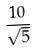<formula> <loc_0><loc_0><loc_500><loc_500>\frac { 1 0 } { \sqrt { 5 } }</formula> 